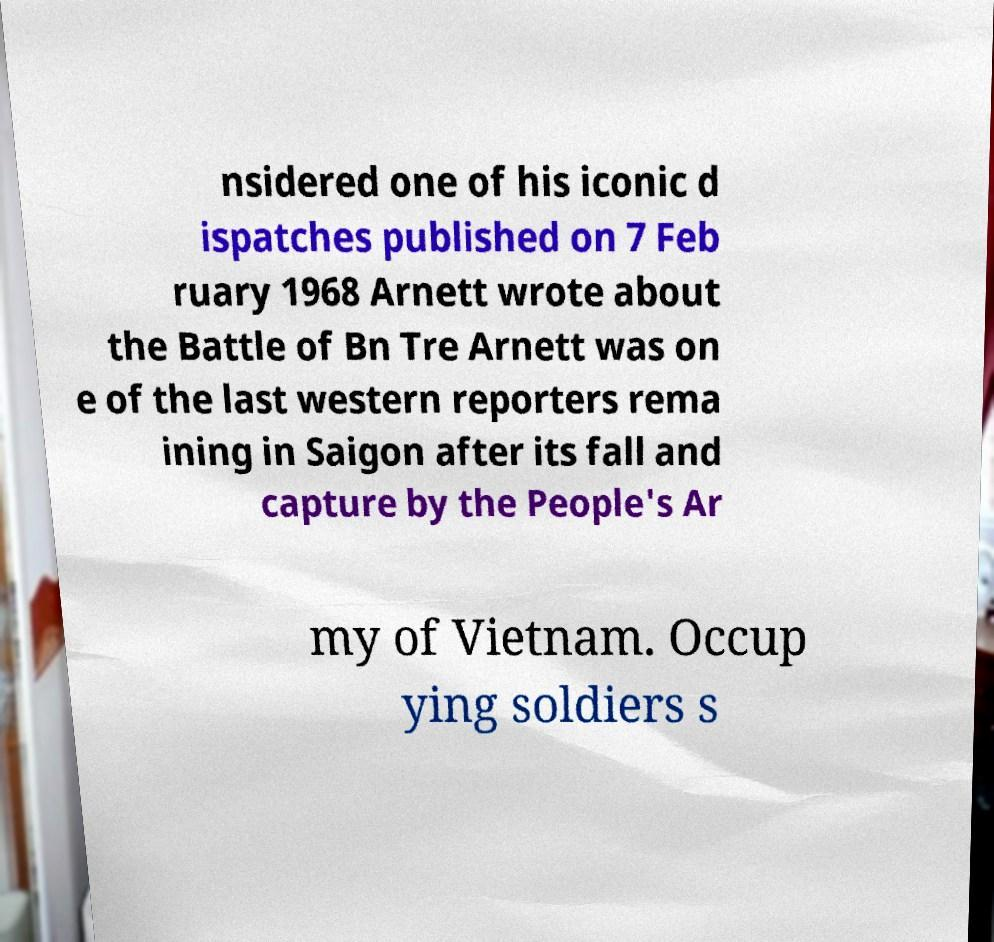There's text embedded in this image that I need extracted. Can you transcribe it verbatim? nsidered one of his iconic d ispatches published on 7 Feb ruary 1968 Arnett wrote about the Battle of Bn Tre Arnett was on e of the last western reporters rema ining in Saigon after its fall and capture by the People's Ar my of Vietnam. Occup ying soldiers s 